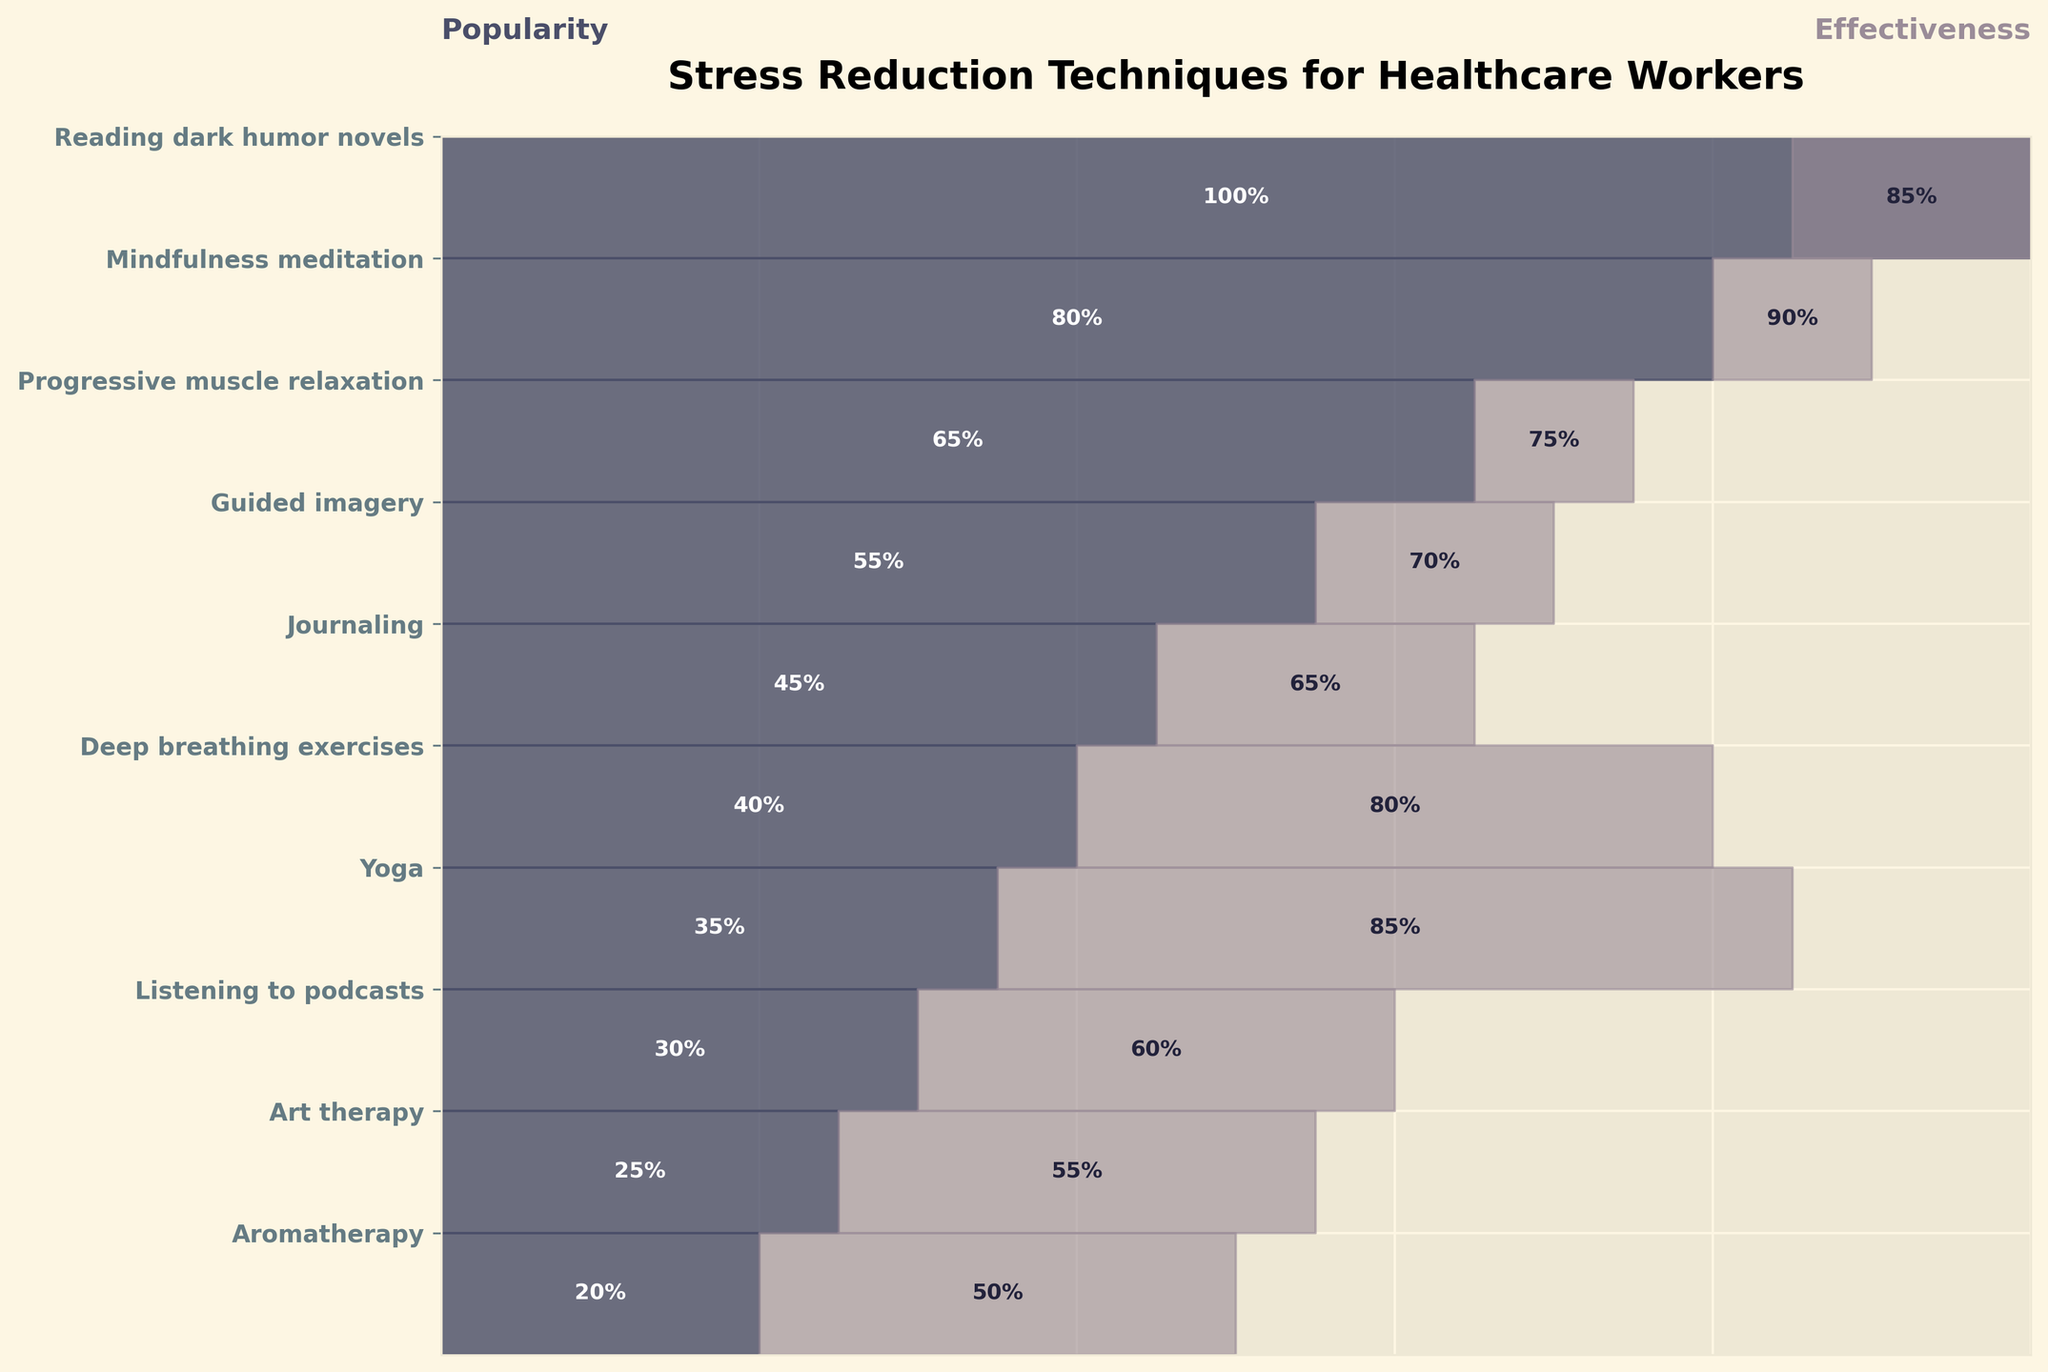What is the popularity percentage of reading dark humor novels? Reading dark humor novels is the first listed technique, and the funnel chart shows 100% popularity for this technique.
Answer: 100% What stress reduction technique has the highest effectiveness? The effectiveness percentages are displayed next to each technique. Mindfulness meditation and yoga both have the highest effectiveness at 90% and 85%, respectively.
Answer: Mindfulness meditation How many stress reduction techniques have a popularity of at least 50%? Reading dark humor novels, mindfulness meditation, progressive muscle relaxation, and guided imagery all have a popularity of at least 50%. These are the first four techniques in the funnel chart.
Answer: 4 What is the difference in effectiveness between deep breathing exercises and listening to podcasts? Deep breathing exercises have an effectiveness of 80%, while listening to podcasts has an effectiveness of 60%. The difference is 80% - 60%.
Answer: 20% Which technique has the greatest disparity between popularity and effectiveness? By inspecting the differences, deep breathing exercises show a large gap but yoga shows a larger disparity: 50% (i.e., 85% effectiveness and 35% popularity).
Answer: Yoga Which technique is ranked just below progressive muscle relaxation in terms of popularity? Guided imagery is positioned directly below progressive muscle relaxation in the funnel chart and has a popularity of 55%.
Answer: Guided imagery If you combine the popularity percentages of aromatherapy and art therapy, what is the total percentage? Aromatherapy has a popularity of 20%, and art therapy has a popularity of 25%. The sum is 20% + 25%.
Answer: 45% Looking at the effectiveness data, are there more techniques above 75% effectiveness or below 75% effectiveness? Techniques above 75% effectiveness include reading dark humor novels, mindfulness meditation, deep breathing exercises, and yoga (4 techniques). Techniques at or below 75% effectiveness include progressive muscle relaxation, guided imagery, journaling, listening to podcasts, and art therapy (6 techniques). Aromatherapy has 50%.
Answer: Below 75% Between journaling and guided imagery, which technique is more popular and by how much? Guided imagery has a popularity of 55%, while journaling has 45%. The difference is 55% - 45%.
Answer: Guided imagery by 10% Based on the chart, which technique has the lowest effectiveness and how effective is it? Looking at the effectiveness column, aromatherapy is shown to have the lowest effectiveness at 50%.
Answer: Aromatherapy, 50% 